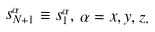Convert formula to latex. <formula><loc_0><loc_0><loc_500><loc_500>s _ { N + 1 } ^ { \alpha } \equiv s _ { 1 } ^ { \alpha } , \, \alpha = x , y , z .</formula> 